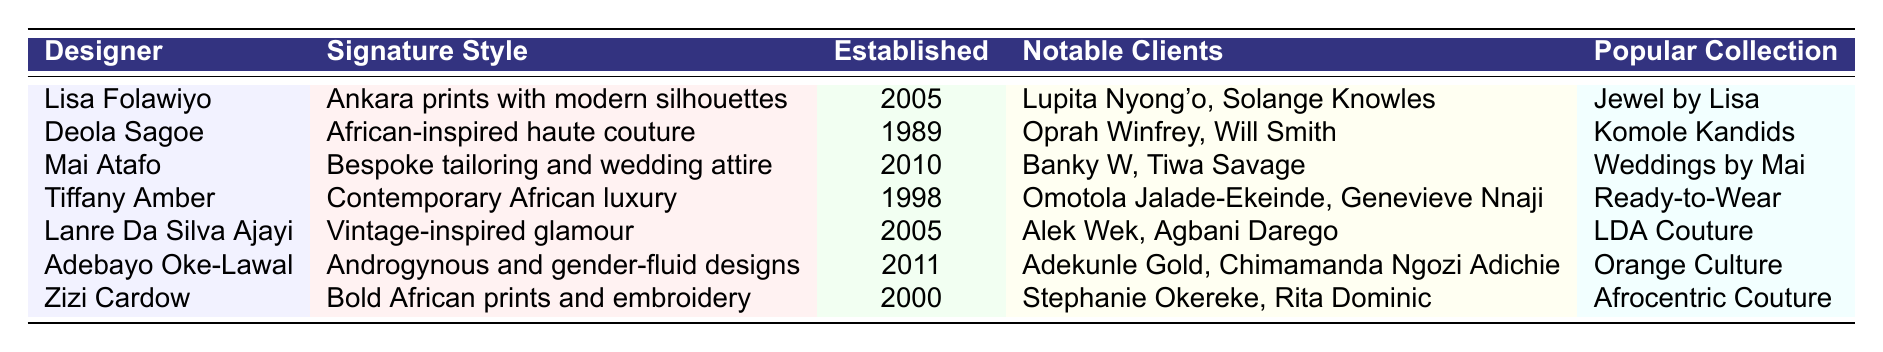What is the signature style of Lisa Folawiyo? The table shows that Lisa Folawiyo's signature style is "Ankara prints with modern silhouettes."
Answer: Ankara prints with modern silhouettes Which designer specializes in bespoke tailoring and wedding attire? According to the table, the designer known for bespoke tailoring and wedding attire is Mai Atafo.
Answer: Mai Atafo How many designers were established after 2000? The designers established after 2000 are Lisa Folawiyo (2005), Mai Atafo (2010), Adebayo Oke-Lawal (2011). Counting these, there are 3 designers.
Answer: 3 What notable clients has Deola Sagoe worked with? The table lists Oprah Winfrey and Will Smith as notable clients of Deola Sagoe.
Answer: Oprah Winfrey, Will Smith Is Tiffany Amber known for vintage-inspired glamour? The table indicates that Tiffany Amber's signature style is "Contemporary African luxury," so the statement is false.
Answer: No Which designer has the earliest establishment year and what is that year? By examining the table, Deola Sagoe is listed as established in 1989, which is the earliest year among the designers.
Answer: 1989 How many of the listed designers focus on gender-fluid designs? The table shows only Adebayo Oke-Lawal focuses on gender-fluid designs, confirming there is 1 designer.
Answer: 1 What is the popular collection of Zizi Cardow? The table states that Zizi Cardow's popular collection is "Afrocentric Couture."
Answer: Afrocentric Couture Who among the designers has worked with both Lupita Nyong'o and Solange Knowles? Lisa Folawiyo is mentioned as having notable clients that include both Lupita Nyong'o and Solange Knowles.
Answer: Lisa Folawiyo Which year did Lanre Da Silva Ajayi establish their brand? According to the table, Lanre Da Silva Ajayi established their brand in 2005.
Answer: 2005 